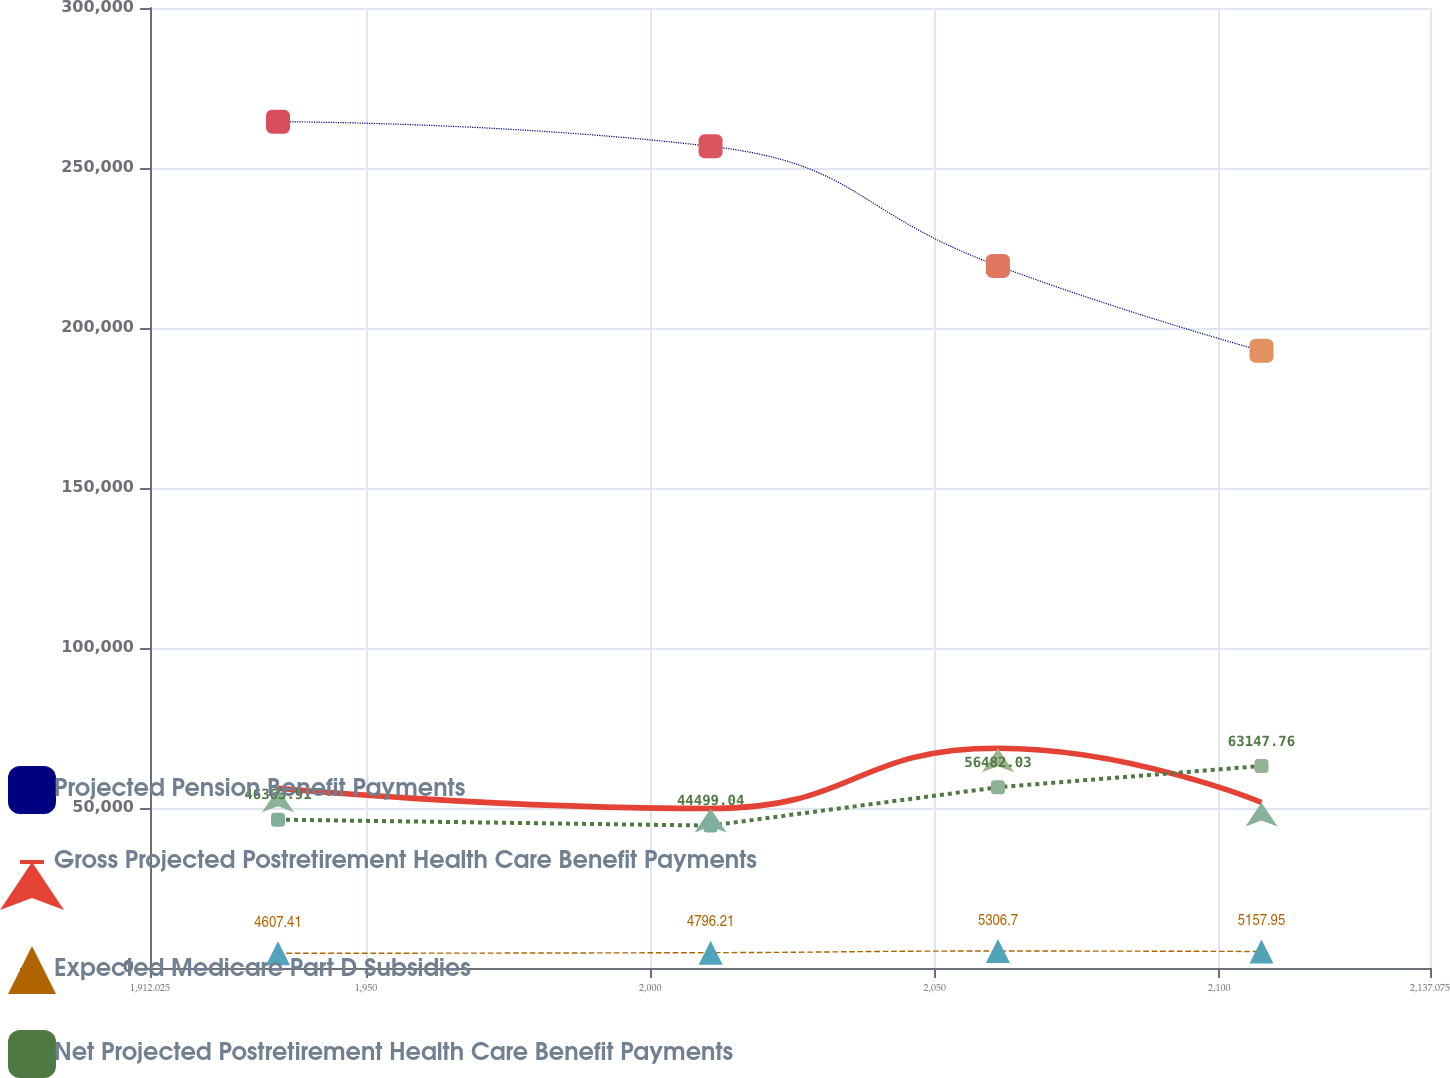<chart> <loc_0><loc_0><loc_500><loc_500><line_chart><ecel><fcel>Projected Pension Benefit Payments<fcel>Gross Projected Postretirement Health Care Benefit Payments<fcel>Expected Medicare Part D Subsidies<fcel>Net Projected Postretirement Health Care Benefit Payments<nl><fcel>1934.53<fcel>264450<fcel>56159.8<fcel>4607.41<fcel>46363.9<nl><fcel>2010.59<fcel>256774<fcel>49832.1<fcel>4796.21<fcel>44499<nl><fcel>2061.11<fcel>219414<fcel>68681.2<fcel>5306.7<fcel>56482<nl><fcel>2107.45<fcel>192859<fcel>51717<fcel>5157.95<fcel>63147.8<nl><fcel>2159.58<fcel>212255<fcel>66113.4<fcel>5905.9<fcel>48228.8<nl></chart> 